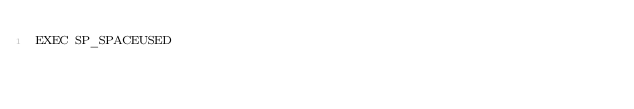<code> <loc_0><loc_0><loc_500><loc_500><_SQL_>EXEC SP_SPACEUSED</code> 